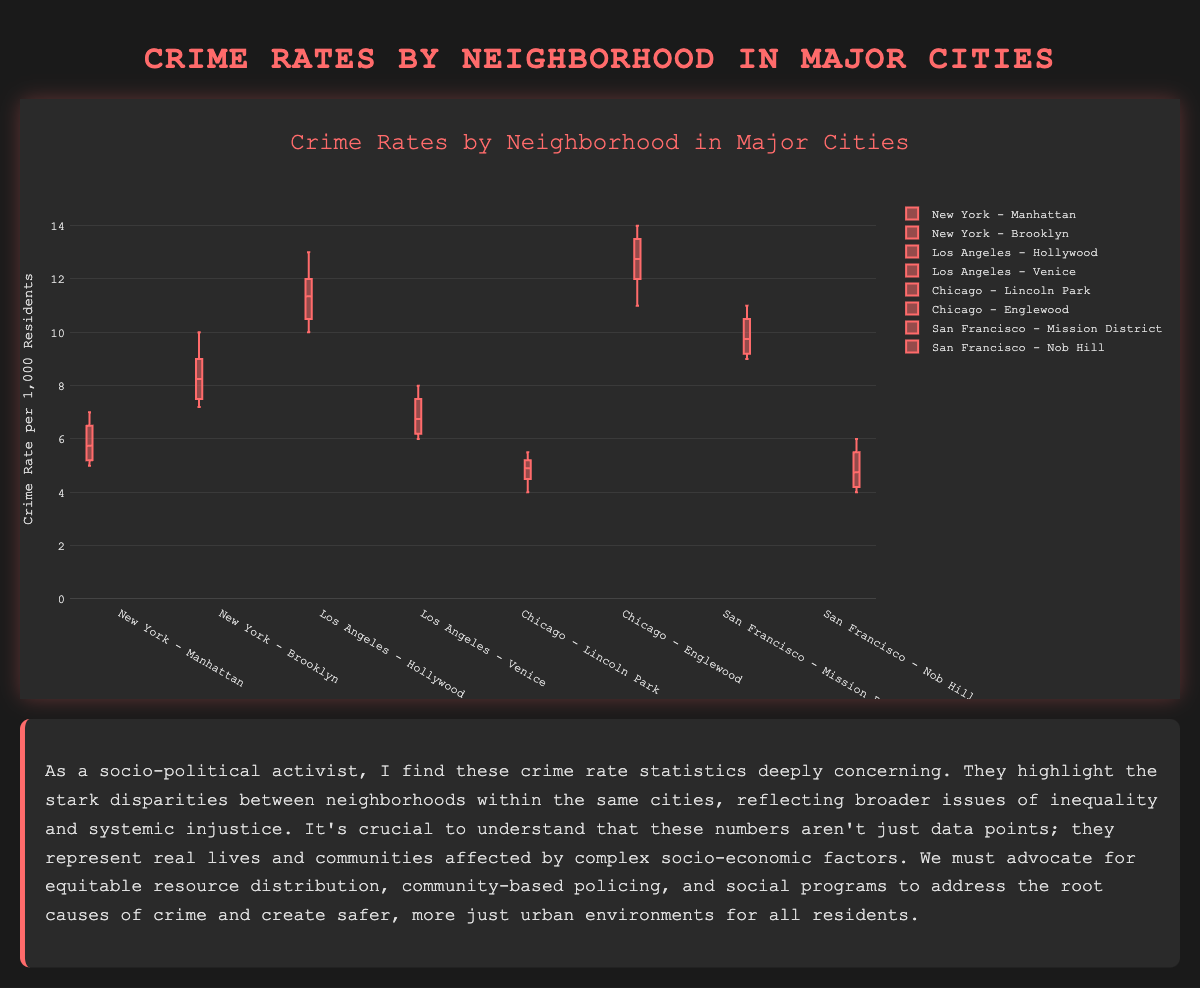What is the title of the box plot? The title is usually displayed at the top of the chart, and it summarizes the overall subject of the plot.
Answer: Crime Rates by Neighborhood in Major Cities What is the range of the y-axis? The range of the y-axis can be determined by looking at the minimum and maximum labels on the axis.
Answer: 0 to 15 Which neighborhood in Los Angeles has the higher crime rate? To answer this, compare the boxes representing neighborhoods in Los Angeles. Hollywood will generally have higher values compared to Venice.
Answer: Hollywood What is the median crime rate in Manhattan? The median is the middle value in the sorted data set, represented by the line inside the box. Based on the data, the median in Manhattan appears to be around 6.
Answer: 6 How does the interquartile range (IQR) of Englewood compare to Lincoln Park in Chicago? The IQR is the range between the first and third quartiles (bottom and top edges of the box). Englewood’s IQR in Chicago, based on its data, will likely be larger than Lincoln Park's, showing more variability in crime rates.
Answer: Englewood has a larger IQR than Lincoln Park Which neighborhood in the dataset has the lowest median crime rate? Identify the neighborhood with the lowest median line inside the box. Nob Hill in San Francisco and Lincoln Park in Chicago seem to have low medians, but Nob Hill will likely be lower.
Answer: Nob Hill What's the difference in the upper quartile value between Brooklyn and Hollywood? The upper quartile is the top edge of the box. For Brooklyn, it is around 9, and for Hollywood, it is about 12. The difference would be 12 - 9 = 3.
Answer: 3 In which city do the neighborhoods show the greatest disparity in crime rates? Look for the city where box plots for different neighborhoods have significant differences, notably between Manhattan and Brooklyn in New York or Lincoln Park and Englewood in Chicago. Chicago has quite a stark disparity.
Answer: Chicago Which neighborhood has the widest range of crime rates? The range is the difference between the highest and lowest data points. Englewood in Chicago, with a range from 11 to 14, shows a wide range.
Answer: Englewood Is there any overlap in the crime rate distributions of Mission District and Hollywood? Overlap can be identified if the boxes and whiskers of these neighborhoods intersect or touch at any point. Both neighborhoods have high values, but based on the detailed comparison, overlap should exist.
Answer: Yes 